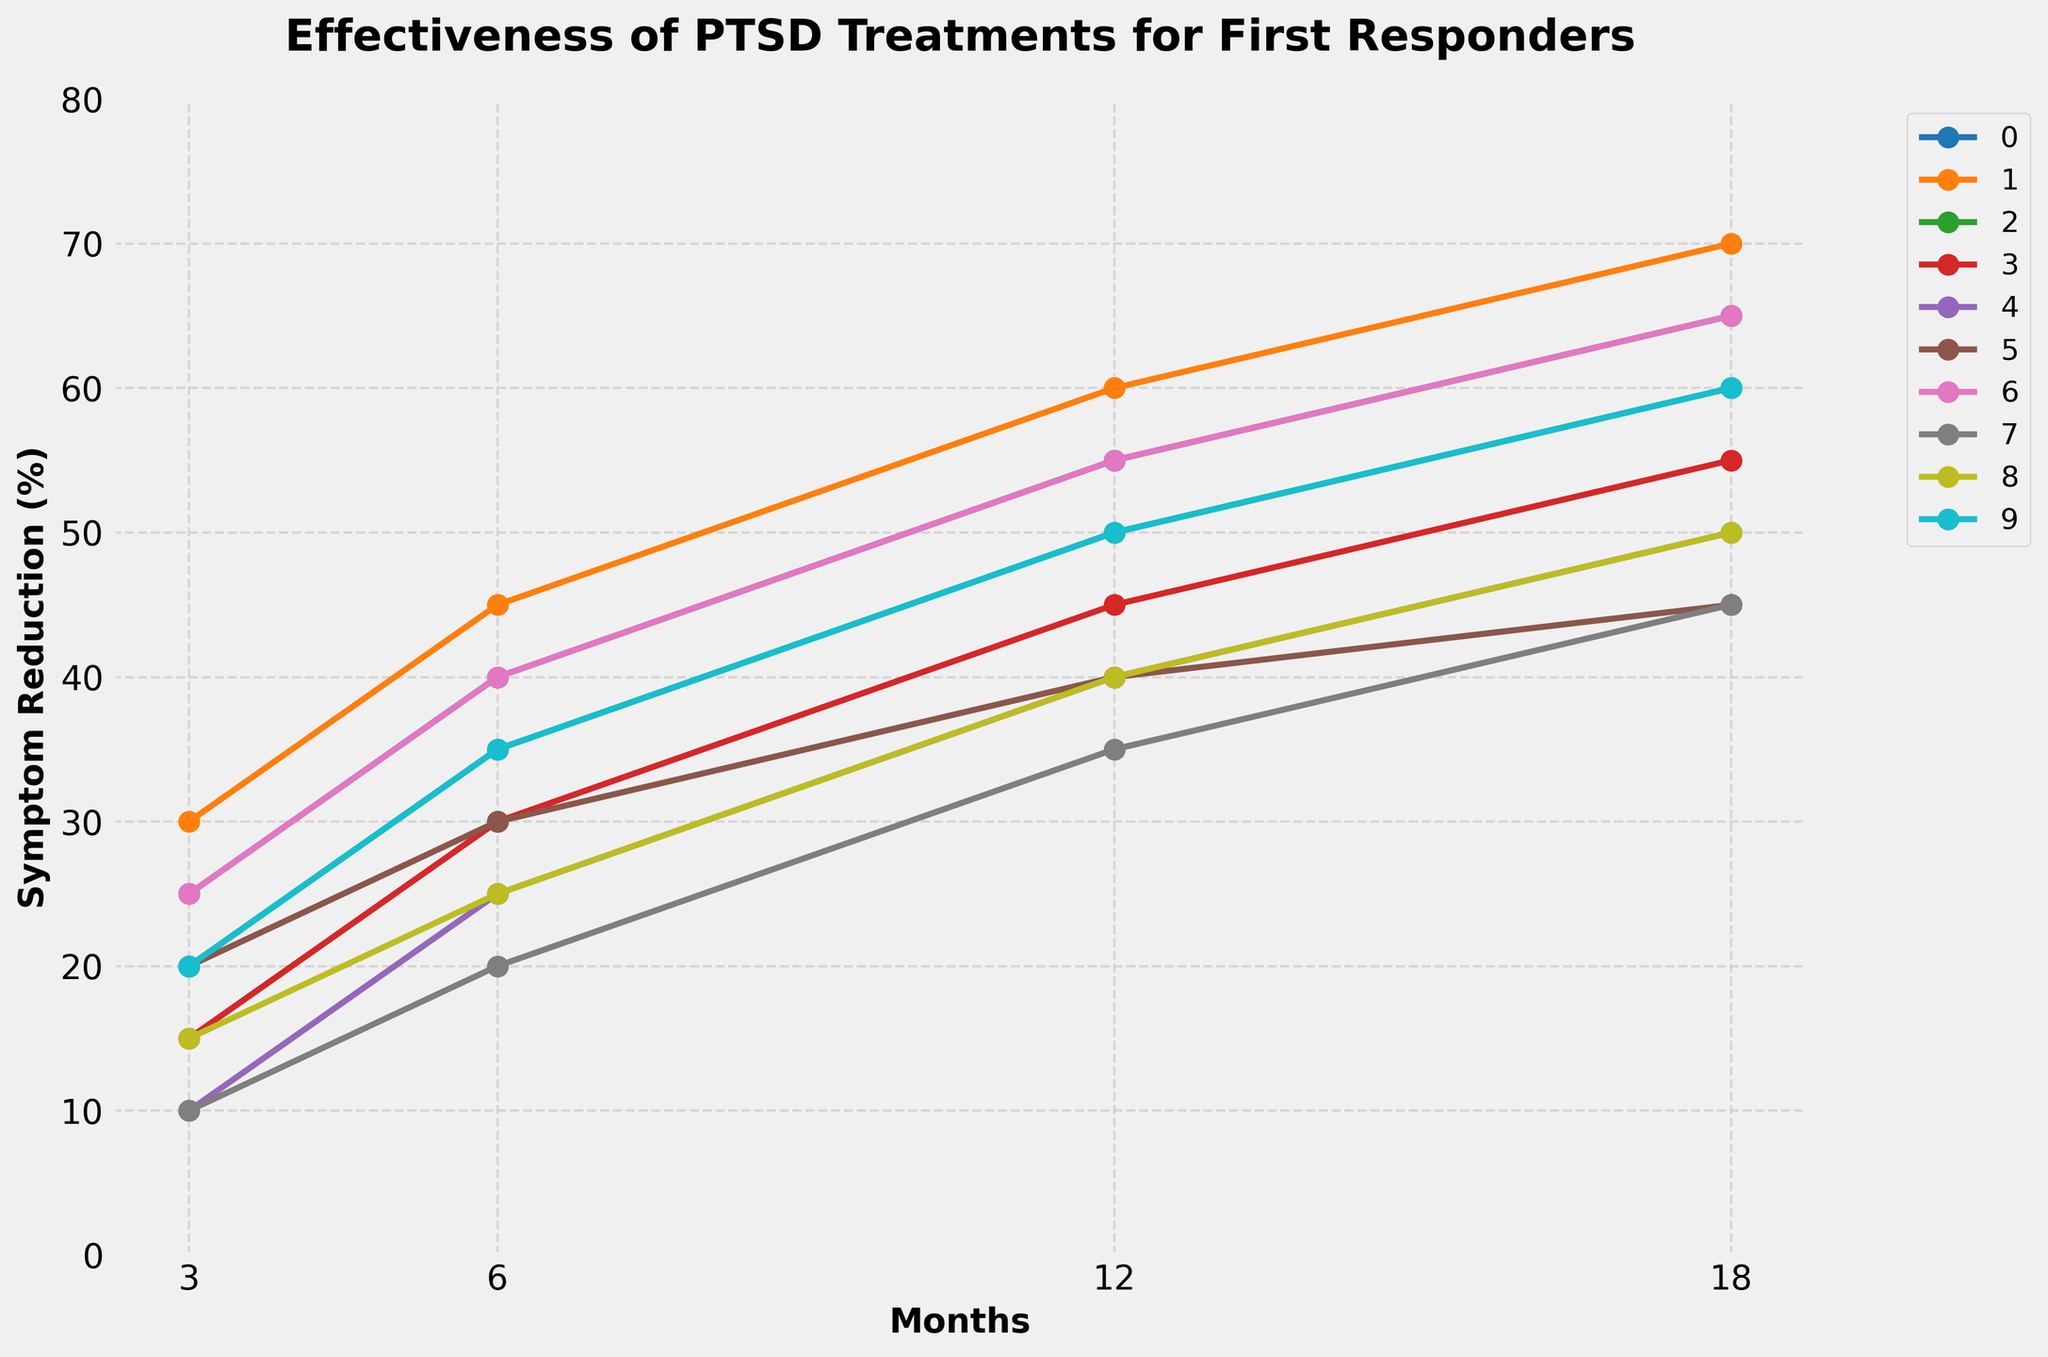Which treatment shows the greatest symptom reduction at 18 months? Refer to the end of the lines in the figure at 18 months and identify the one with the highest value. EMDR at 70% is the highest.
Answer: EMDR What is the difference in symptom reduction between Cognitive Processing Therapy and Group Therapy at 6 months? Check the values for both treatments at 6 months and subtract the smaller value (Group Therapy 25%) from the bigger value (Cognitive Processing Therapy 40%). 40% - 25% = 15%
Answer: 15% Which two treatments show equal symptom reduction at 18 months? Look at each treatment’s value at 18 months and see which ones are equal. Cognitive Processing Therapy and Virtual Reality Exposure Therapy both have a symptom reduction of 65% at 18 months.
Answer: Cognitive Processing Therapy and Virtual Reality Exposure Therapy On average, what is the symptom reduction at 3 months across all treatments? Add the 3-month values for each treatment and divide by the number of treatments: (25+30+20+15+10+20+25+10+15+20)/10 = 19%
Answer: 19% Does any treatment show a steady increase in symptom reduction across all time points? Look for treatments where the symptom reduction consistently increases from 3 to 6 to 12 to 18 months without dipping. All treatments exhibit a steady increase.
Answer: Yes How much more effective is EMDR compared to Medication (SSRIs) at 12 months? Find the values for EMDR and Medication (SSRIs) at 12 months and compute the difference: 60% - 40% = 20%
Answer: 20% Which treatment has the smallest symptom reduction at 3 months? Identify the treatment with the lowest value at the 3-month mark. Group Therapy has the smallest symptom reduction at 10%.
Answer: Group Therapy What is the combined symptom reduction of Prolonged Exposure Therapy and Yoga and Meditation at 18 months? Add the symptom reduction values for both treatments at 18 months: 60% + 50% = 110%
Answer: 110% Which treatment's line is colored blue? Identify the treatment by the color of the line. Since line colors are not mentioned in the data or code, this cannot be accurately answered without the chart.
Answer: Not visible (requires chart) Between Cognitive Processing Therapy and Art Therapy, which treatment shows a greater increase in symptom reduction from 3 months to 18 months? Compute the increase for each treatment from 3 months to 18 months and compare them: Cognitive Processing Therapy (65% - 25% = 40%), Art Therapy (45% - 10% = 35%). Cognitive Processing Therapy shows a higher increase.
Answer: Cognitive Processing Therapy 